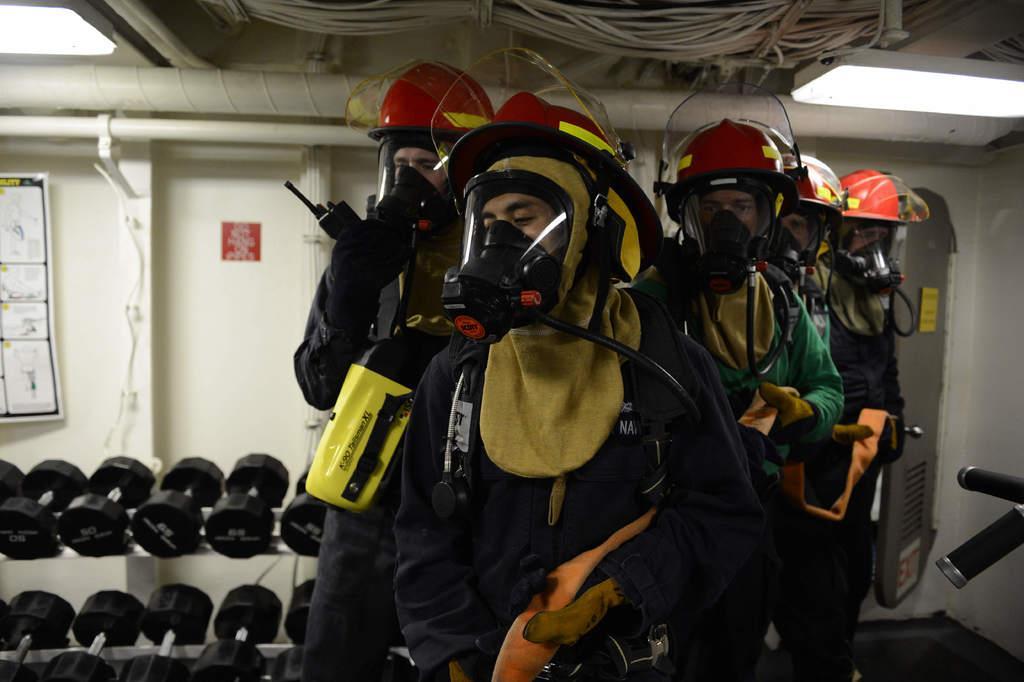In one or two sentences, can you explain what this image depicts? In this image, we can see people wearing oxygen helmets and in the background, there are dumbbells and at the top, we can see wires and there is a board placed on the wall. 